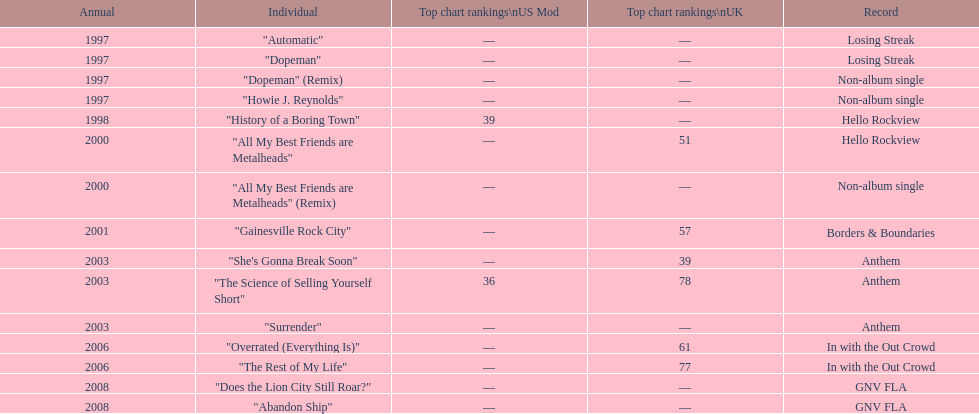What was the next single after "overrated (everything is)"? "The Rest of My Life". 